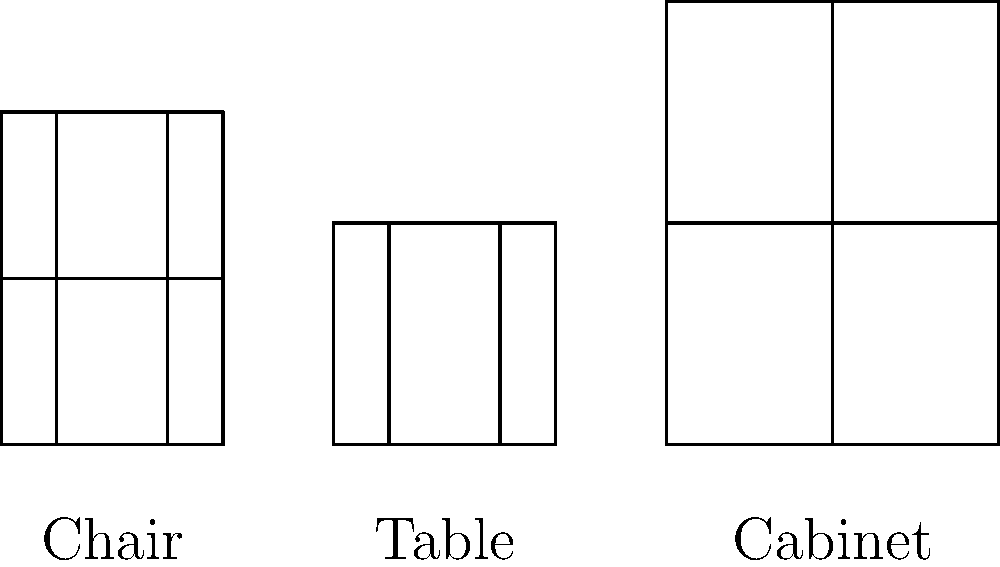Compare the proportions of the Shaker furniture pieces shown in the simple line drawings. Which piece exhibits the highest height-to-width ratio, and how does this reflect Shaker design principles? To answer this question, we need to follow these steps:

1. Calculate the height-to-width ratio for each piece:

   a. Chair: Height = 60 units, Width = 40 units
      Ratio = 60/40 = 1.5
   
   b. Table: Height = 40 units, Width = 40 units
      Ratio = 40/40 = 1

   c. Cabinet: Height = 80 units, Width = 60 units
      Ratio = 80/60 ≈ 1.33

2. Compare the ratios:
   The chair has the highest ratio at 1.5, followed by the cabinet at 1.33, and then the table at 1.

3. Analyze how this reflects Shaker design principles:
   - Shaker furniture is known for its simplicity, functionality, and proportional harmony.
   - The chair's higher height-to-width ratio reflects the need for a tall, straight back for proper posture and comfort.
   - This design also maximizes vertical space efficiency, a key principle in Shaker design.
   - The taller proportion of the chair embodies the Shaker belief in reaching upward spiritually, while maintaining a sturdy, grounded base.

4. Consider the other pieces:
   - The table and cabinet have lower height-to-width ratios, emphasizing stability and horizontal space utilization.
   - These ratios still maintain a balance between vertical and horizontal elements, reflecting the Shaker principle of harmony and proportion.
Answer: The chair, with its emphasis on vertical proportion reflecting Shaker principles of simplicity, functionality, and spiritual aspiration. 